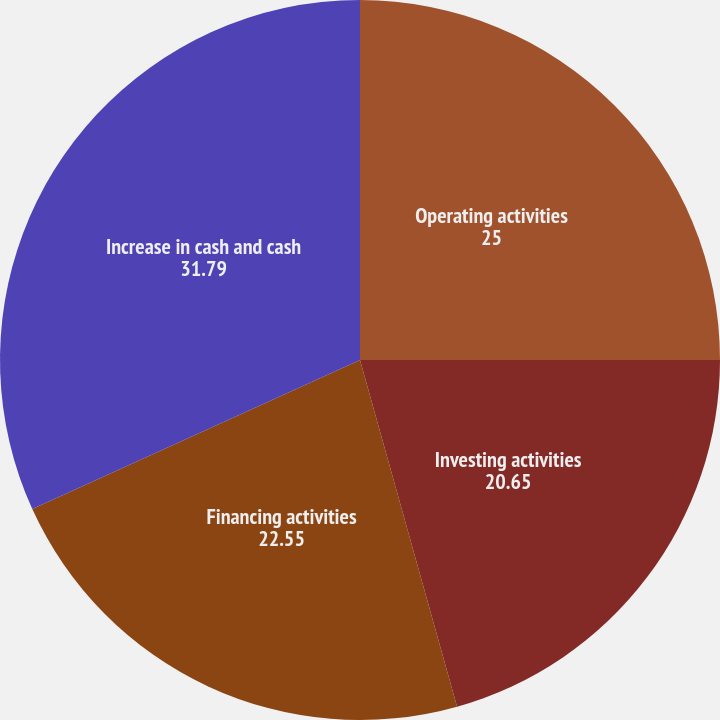Convert chart to OTSL. <chart><loc_0><loc_0><loc_500><loc_500><pie_chart><fcel>Operating activities<fcel>Investing activities<fcel>Financing activities<fcel>Increase in cash and cash<nl><fcel>25.0%<fcel>20.65%<fcel>22.55%<fcel>31.79%<nl></chart> 